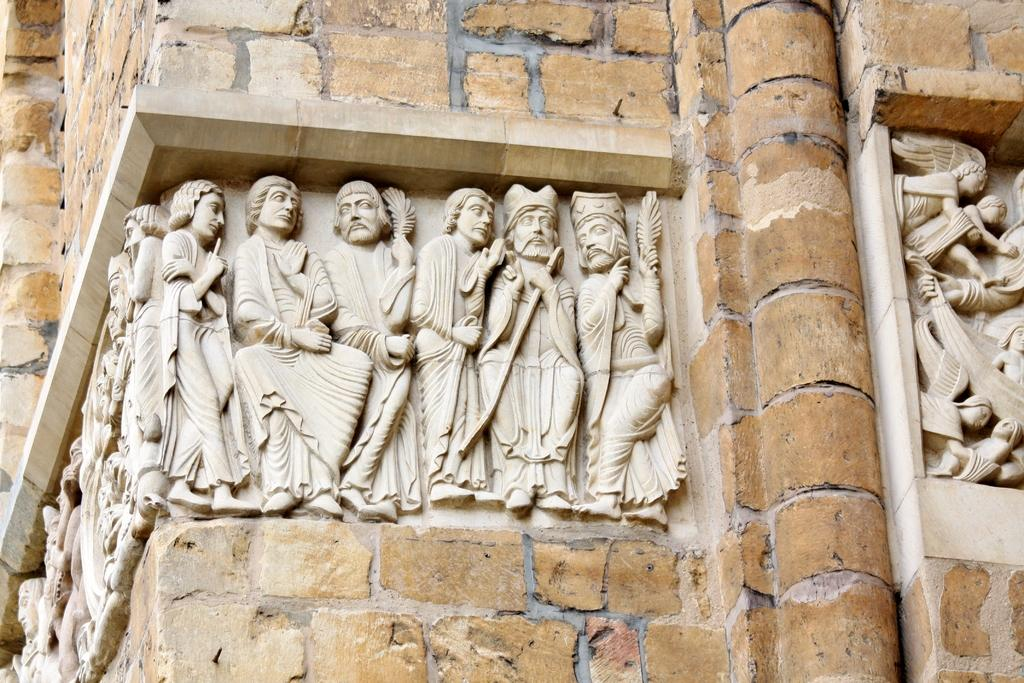What is the main subject in the center of the image? There are sculptures in the center of the image. Can you describe the surroundings of the sculptures? There is a wall in the image. What grade is the plant in the image? There is no plant present in the image. What type of hammer is being used to create the sculptures in the image? There is no hammer visible in the image, and the process of creating the sculptures is not shown. 